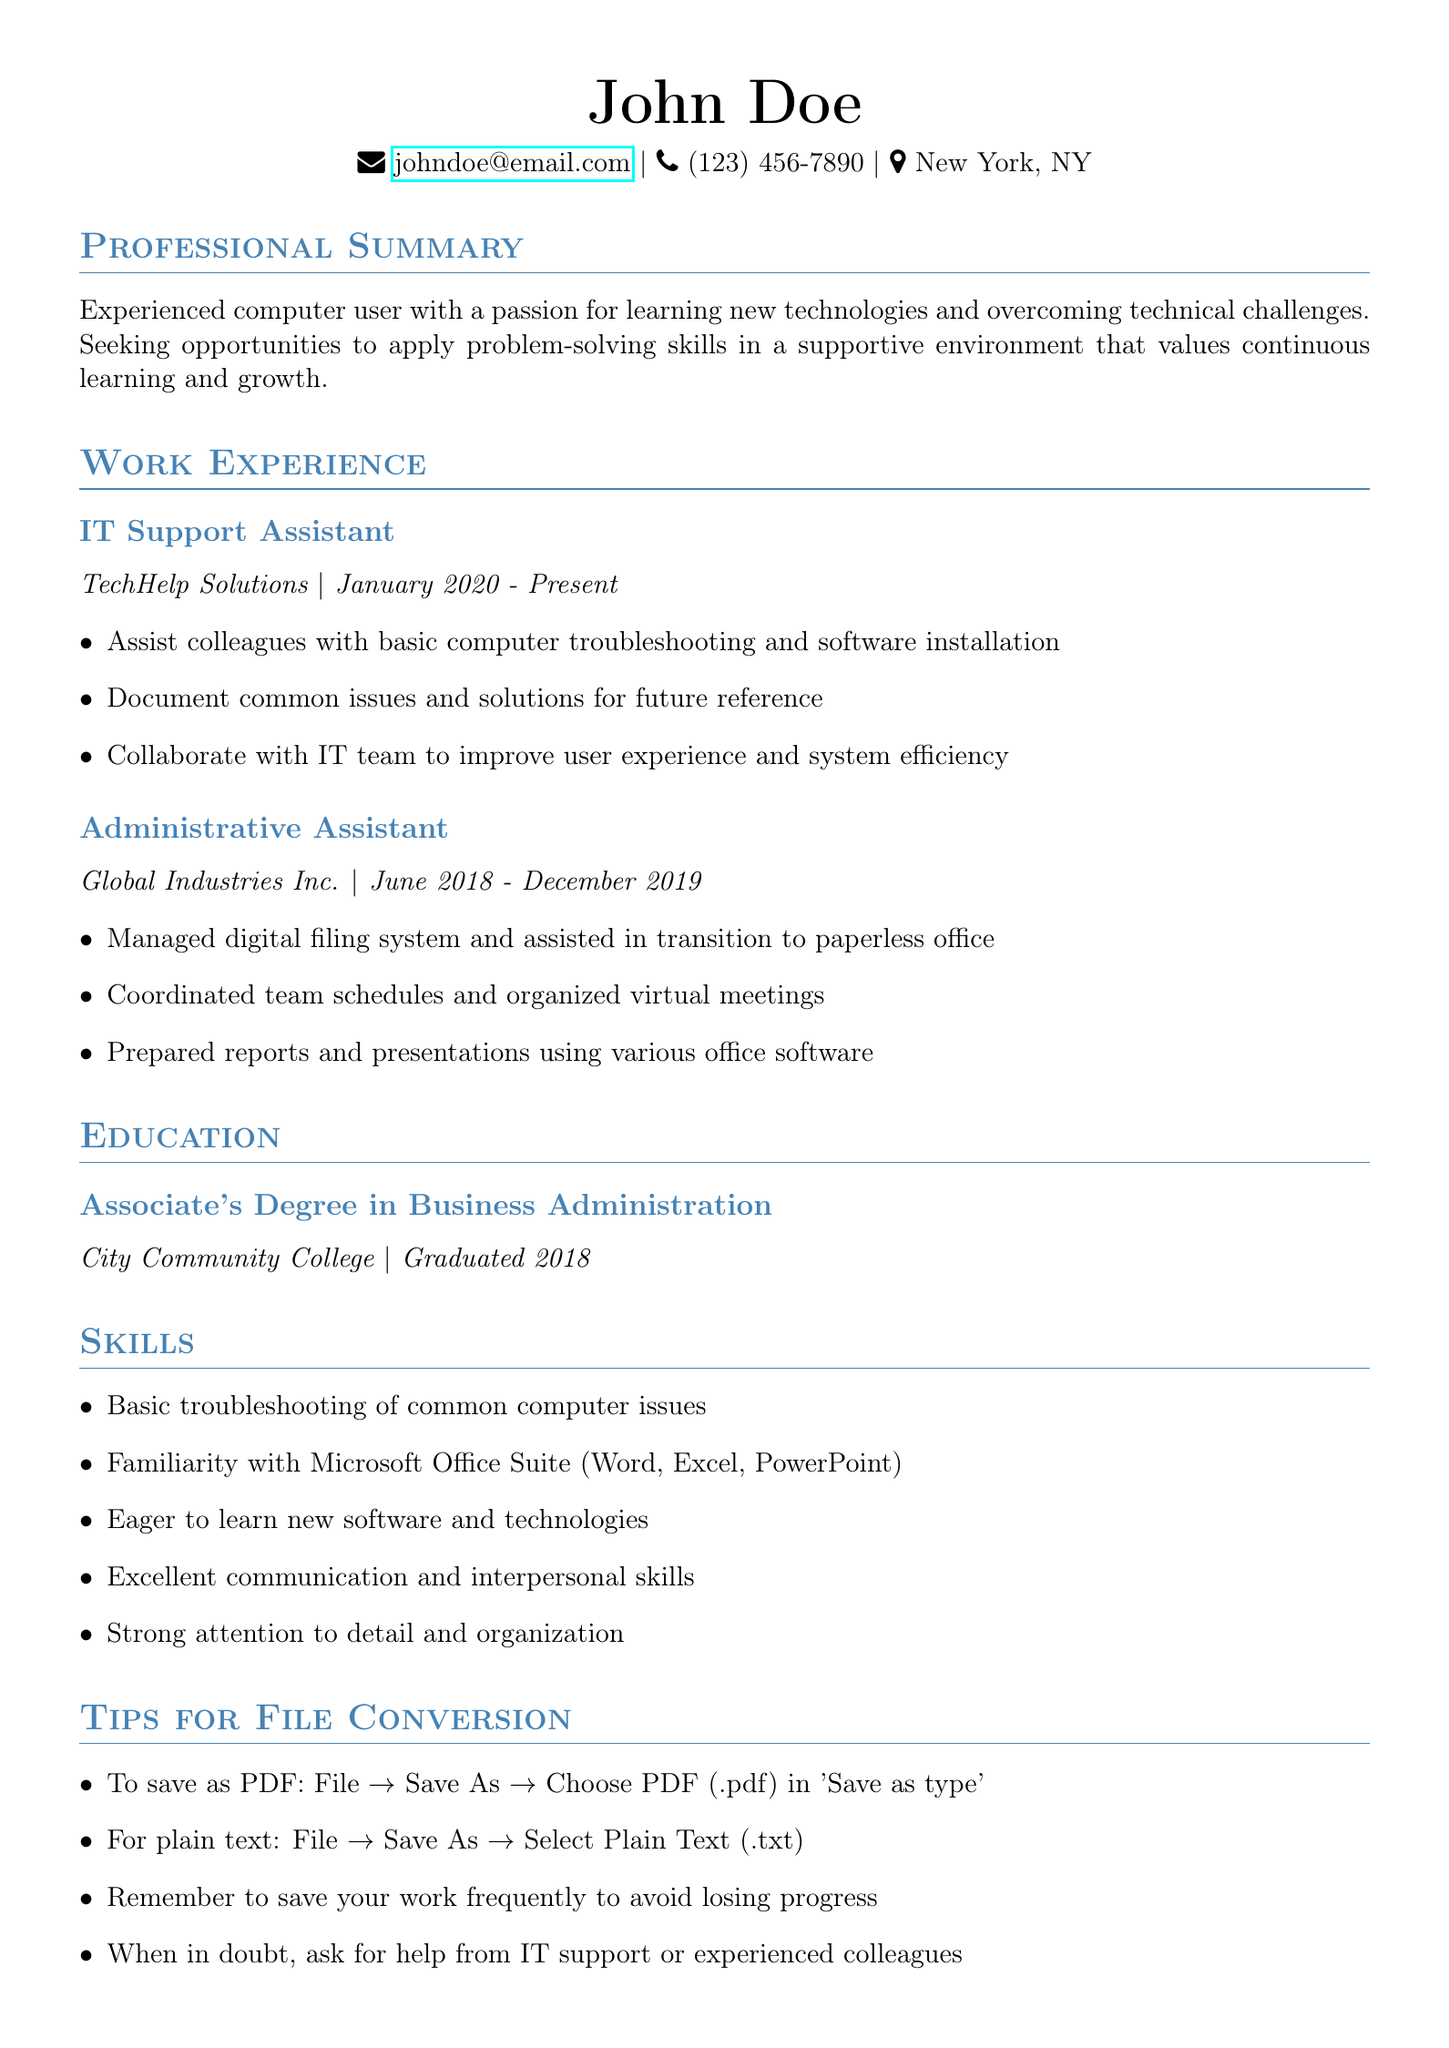what is the full name? The full name is located at the top of the document.
Answer: John Doe what is the email address? The email address is provided in the personal information section.
Answer: johndoe@email.com how many years of work experience are listed? The document lists two positions with specific employment dates, indicating over 3 years of experience.
Answer: Over 3 years what is the degree obtained? The degree is stated in the education section of the CV.
Answer: Associate's Degree in Business Administration which skill indicates a willingness to learn? This skill is mentioned as a relevant skill in the skills section.
Answer: Eager to learn new software and technologies what is the first step to save the document? The first step is mentioned in the saving instructions.
Answer: Click on 'File' how do you save the document as a PDF? The steps for saving as PDF are outlined in the conversion instructions.
Answer: Choose PDF (.pdf) in 'Save as type' what is a tip for writing the CV? The tips section includes several suggestions for CV writing.
Answer: Keep your CV to one page what should you do if you are unsure about something? The tips section provides guidance on seeking help.
Answer: Ask for help from IT support or experienced colleagues 